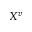<formula> <loc_0><loc_0><loc_500><loc_500>X ^ { v }</formula> 